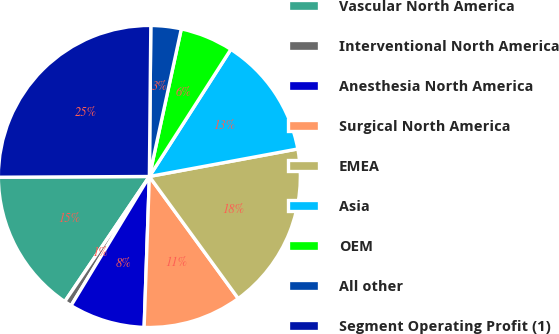Convert chart to OTSL. <chart><loc_0><loc_0><loc_500><loc_500><pie_chart><fcel>Vascular North America<fcel>Interventional North America<fcel>Anesthesia North America<fcel>Surgical North America<fcel>EMEA<fcel>Asia<fcel>OEM<fcel>All other<fcel>Segment Operating Profit (1)<nl><fcel>15.46%<fcel>0.79%<fcel>8.12%<fcel>10.57%<fcel>17.9%<fcel>13.01%<fcel>5.68%<fcel>3.24%<fcel>25.23%<nl></chart> 